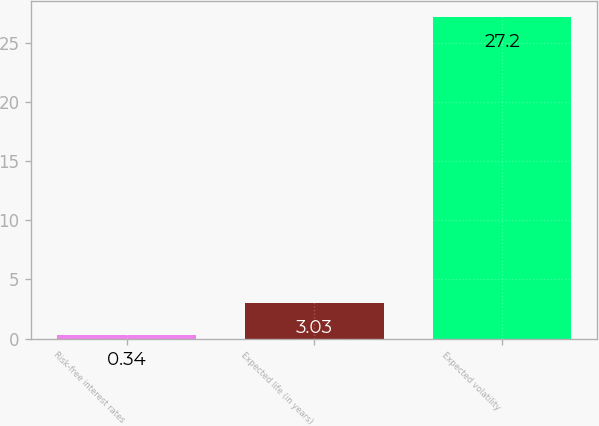Convert chart to OTSL. <chart><loc_0><loc_0><loc_500><loc_500><bar_chart><fcel>Risk-free interest rates<fcel>Expected life (in years)<fcel>Expected volatility<nl><fcel>0.34<fcel>3.03<fcel>27.2<nl></chart> 